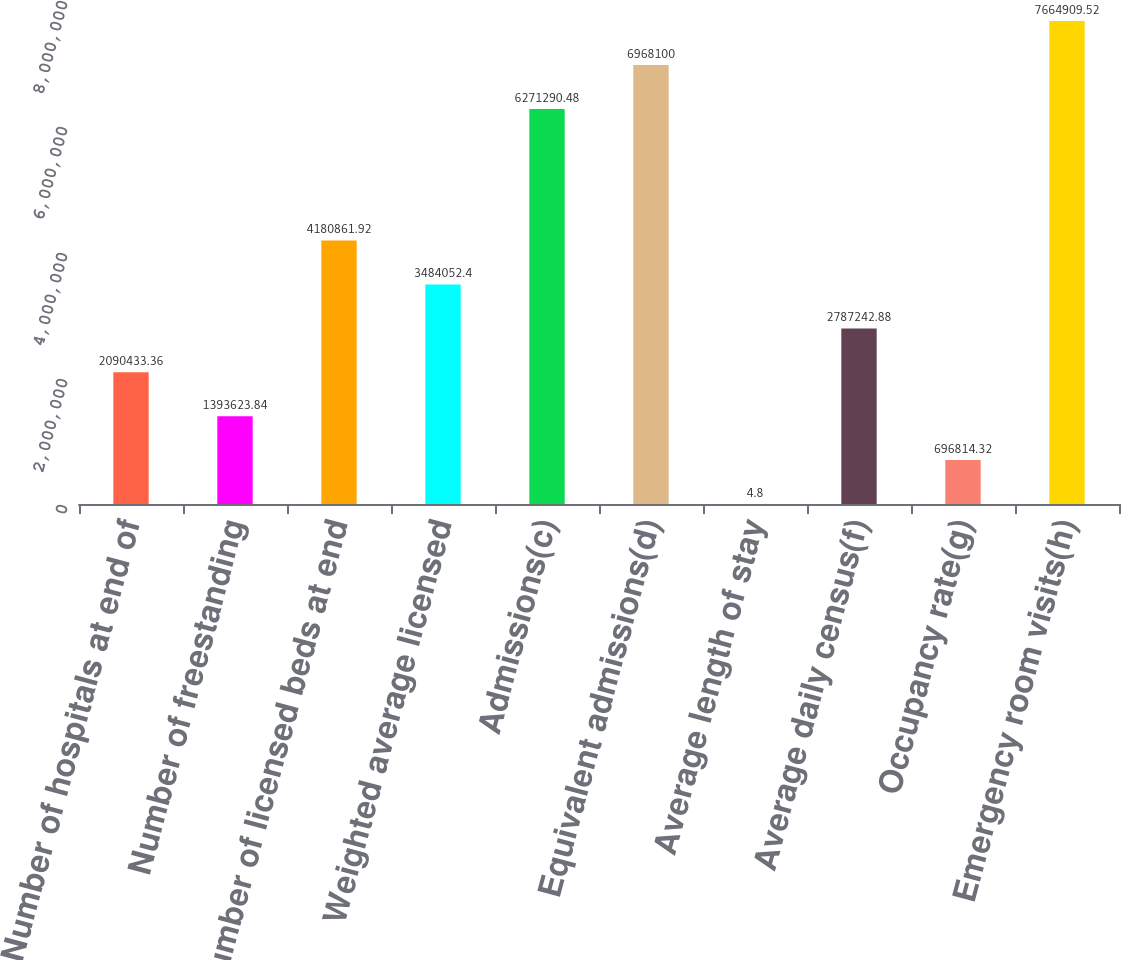Convert chart to OTSL. <chart><loc_0><loc_0><loc_500><loc_500><bar_chart><fcel>Number of hospitals at end of<fcel>Number of freestanding<fcel>Number of licensed beds at end<fcel>Weighted average licensed<fcel>Admissions(c)<fcel>Equivalent admissions(d)<fcel>Average length of stay<fcel>Average daily census(f)<fcel>Occupancy rate(g)<fcel>Emergency room visits(h)<nl><fcel>2.09043e+06<fcel>1.39362e+06<fcel>4.18086e+06<fcel>3.48405e+06<fcel>6.27129e+06<fcel>6.9681e+06<fcel>4.8<fcel>2.78724e+06<fcel>696814<fcel>7.66491e+06<nl></chart> 